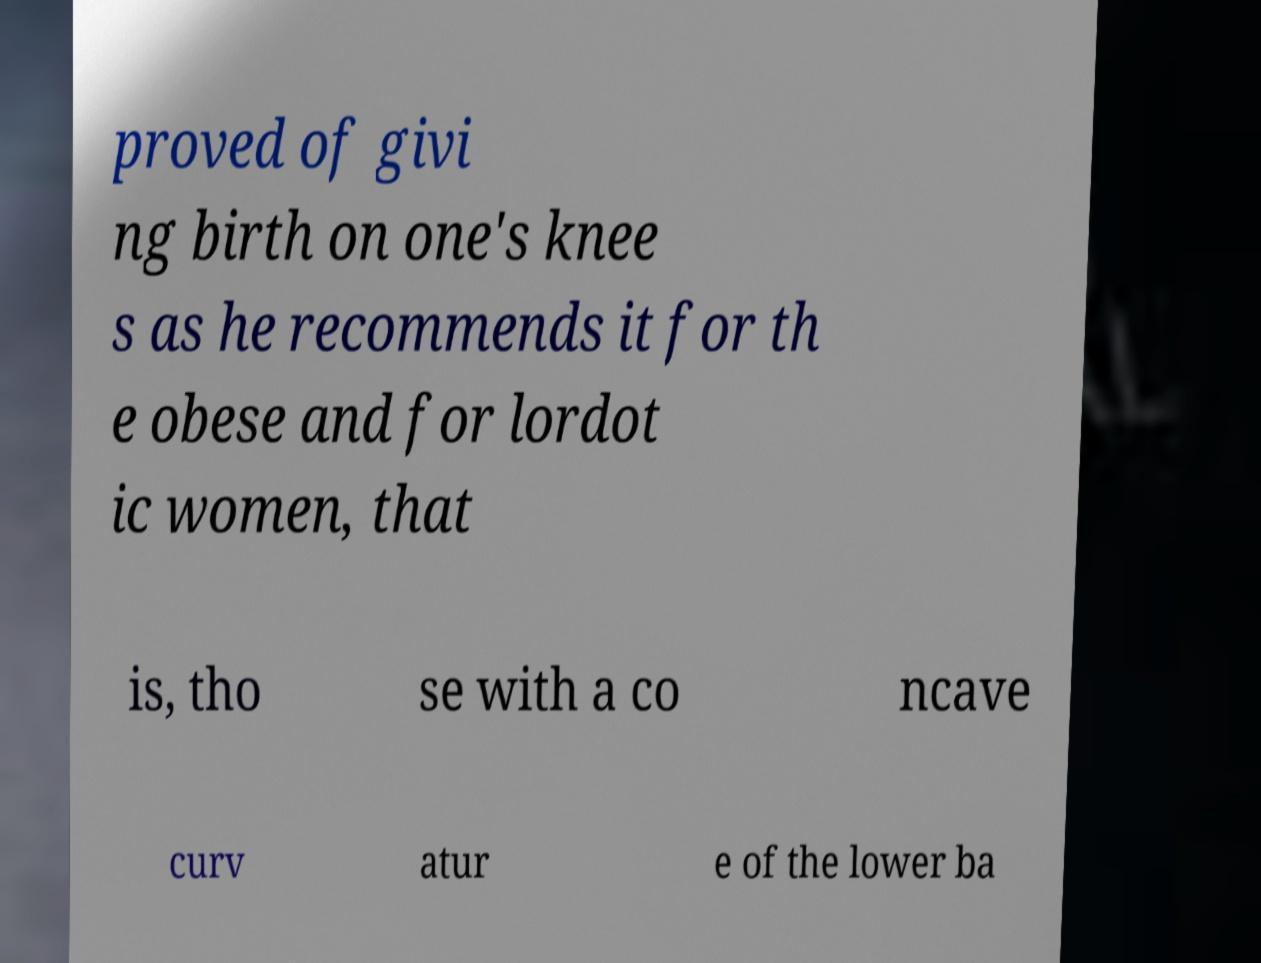Can you read and provide the text displayed in the image?This photo seems to have some interesting text. Can you extract and type it out for me? proved of givi ng birth on one's knee s as he recommends it for th e obese and for lordot ic women, that is, tho se with a co ncave curv atur e of the lower ba 